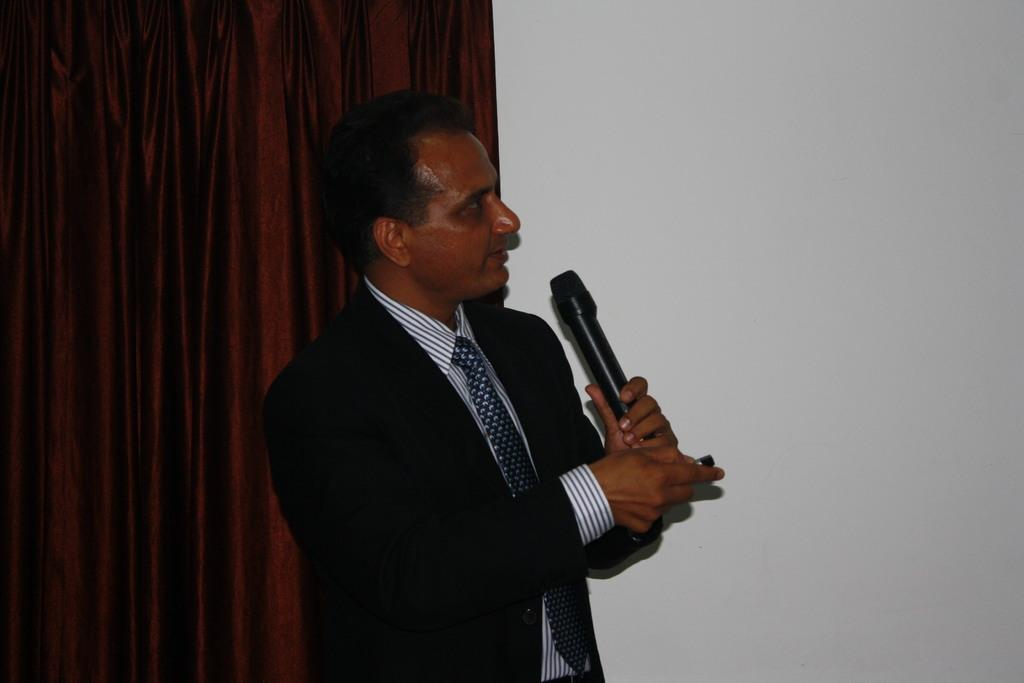Who is the main subject in the picture? There is a person in the center of the picture. What is the person holding in the image? The person is holding a microphone. What is the person doing with the microphone? The person is talking. What can be seen on the left side of the image? There is a red curtain on the left side of the image. What is visible on the right side of the image? There is a white wall on the right side of the image. What scent can be detected in the image? There is no reference to any scent in the image, so it cannot be determined. 